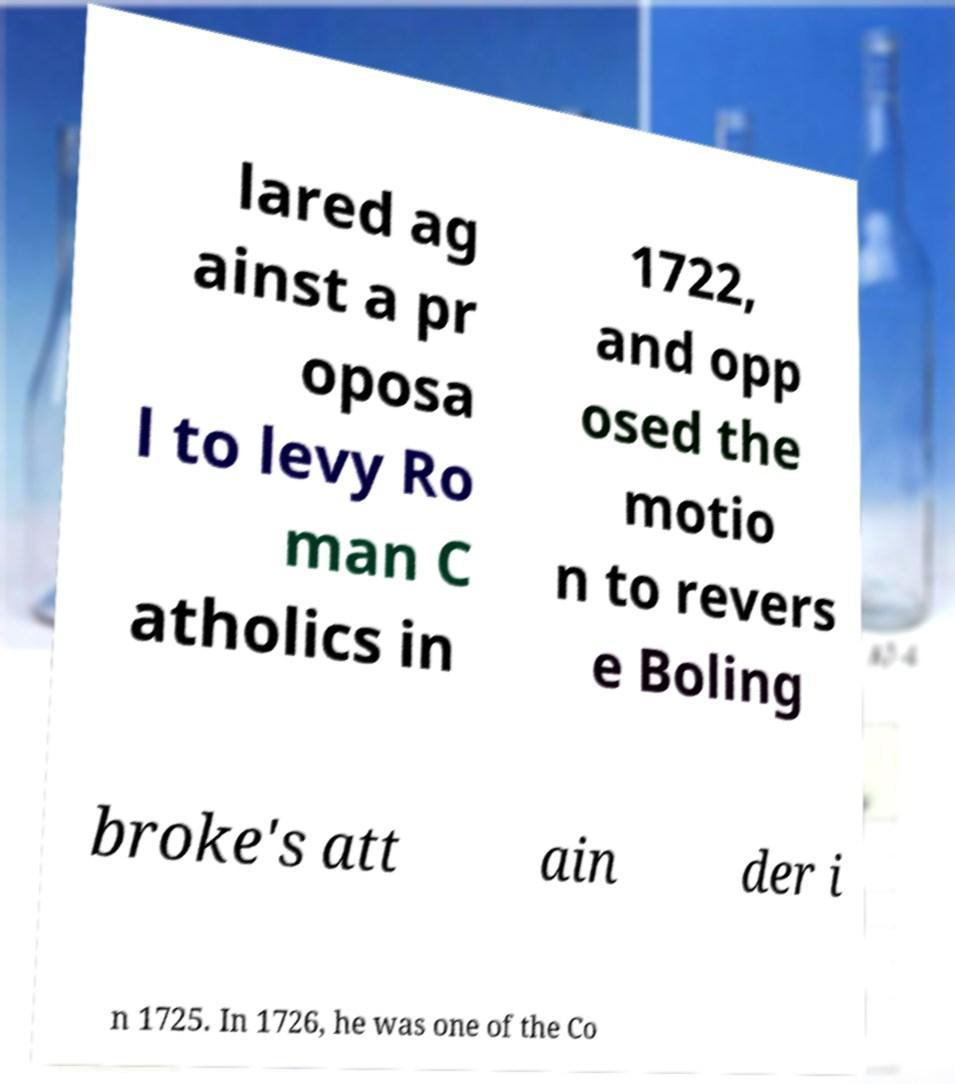Can you accurately transcribe the text from the provided image for me? lared ag ainst a pr oposa l to levy Ro man C atholics in 1722, and opp osed the motio n to revers e Boling broke's att ain der i n 1725. In 1726, he was one of the Co 